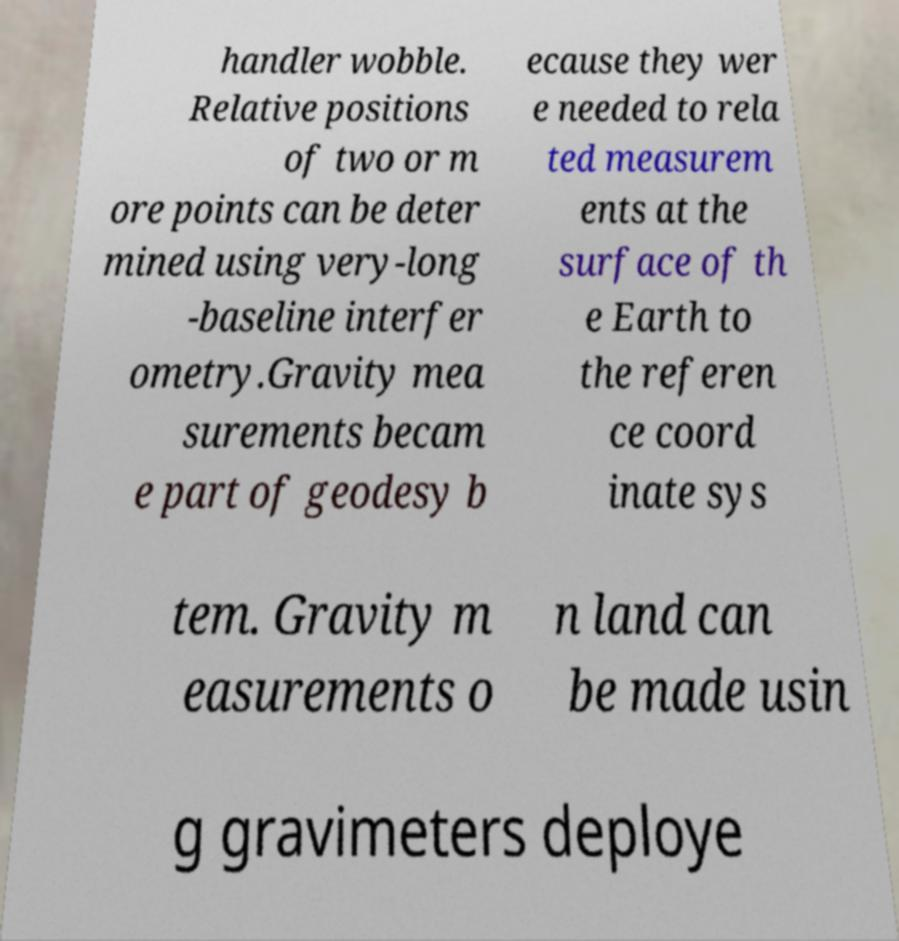What messages or text are displayed in this image? I need them in a readable, typed format. handler wobble. Relative positions of two or m ore points can be deter mined using very-long -baseline interfer ometry.Gravity mea surements becam e part of geodesy b ecause they wer e needed to rela ted measurem ents at the surface of th e Earth to the referen ce coord inate sys tem. Gravity m easurements o n land can be made usin g gravimeters deploye 